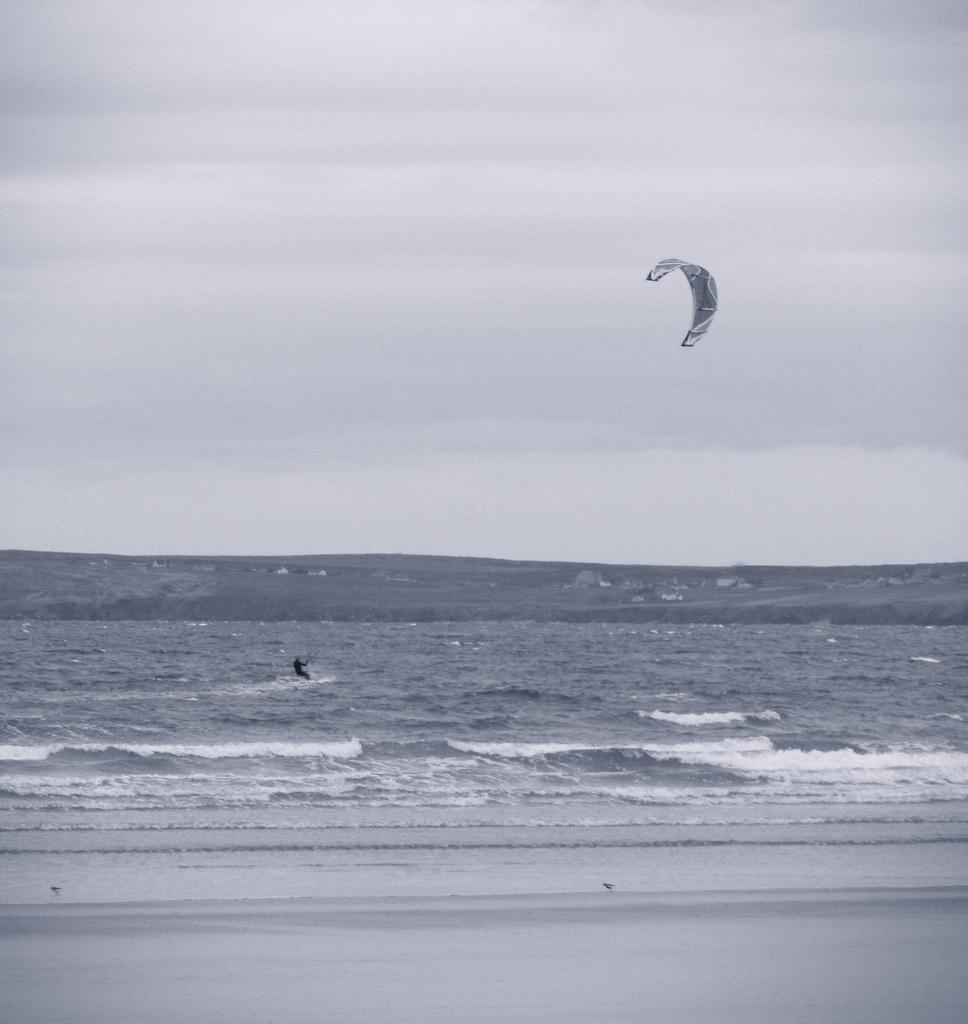Please provide a concise description of this image. In this image there is a person kitesurfing in the sea. 